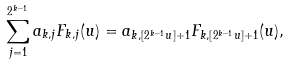Convert formula to latex. <formula><loc_0><loc_0><loc_500><loc_500>\sum _ { j = 1 } ^ { 2 ^ { k - 1 } } a _ { k , j } F _ { k , j } ( u ) = a _ { k , [ 2 ^ { k - 1 } u ] + 1 } F _ { k , [ 2 ^ { k - 1 } u ] + 1 } ( u ) ,</formula> 